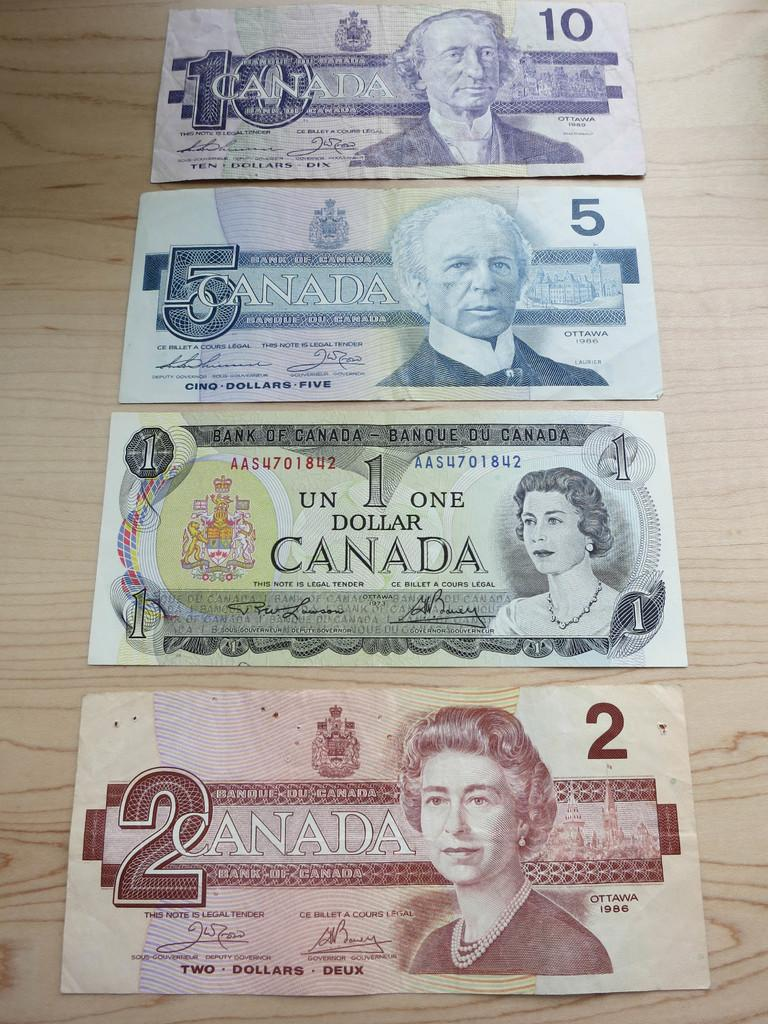What type of objects can be seen in the image? There are currency notes in the image. Can you describe any specific details about the currency notes? There is writing on the currency notes. How does the alarm sound in the image? There is no alarm present in the image; it only features currency notes with writing on them. 